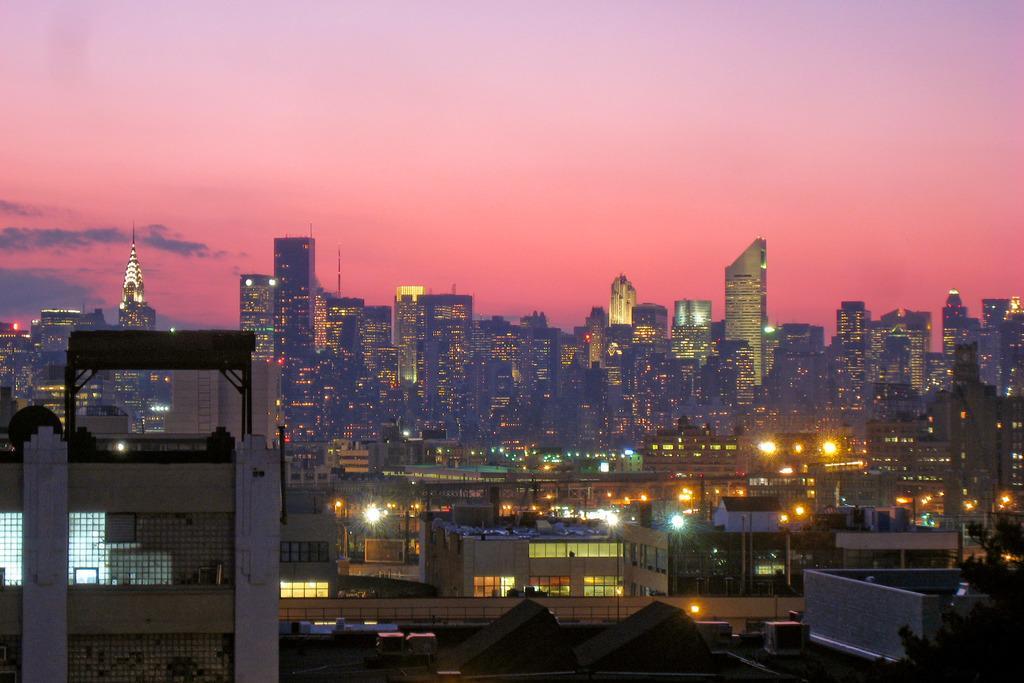In one or two sentences, can you explain what this image depicts? In this image we can many buildings and skyscrapers. We can see a tree at the right side of the image. We can see the sky in the image. We can see few clouds in the sky at the left side of the image. 